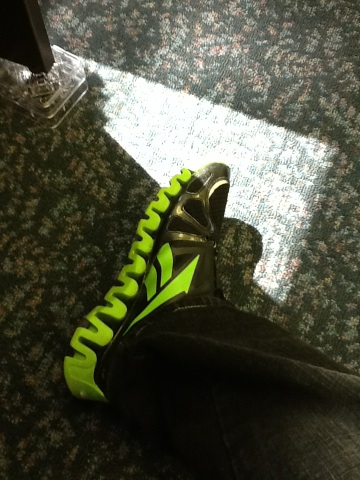What color are those shoes? The shoes in the image are primarily black with striking green accents along the sides and the sole. This color combination gives the shoes a vibrant, sporty look. 